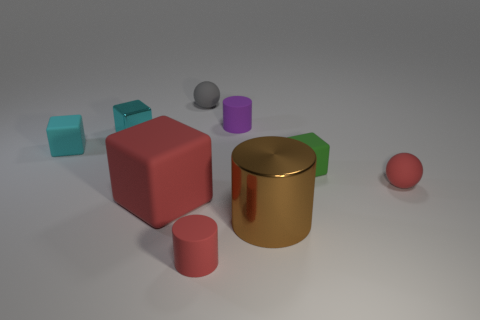Subtract all small purple matte cylinders. How many cylinders are left? 2 Subtract all blocks. How many objects are left? 5 Add 1 big brown things. How many objects exist? 10 Subtract all cyan cubes. How many cubes are left? 2 Subtract all green cylinders. Subtract all cyan cubes. How many cylinders are left? 3 Subtract all brown balls. How many cyan cubes are left? 2 Subtract all big objects. Subtract all purple rubber things. How many objects are left? 6 Add 4 small cyan objects. How many small cyan objects are left? 6 Add 4 red rubber spheres. How many red rubber spheres exist? 5 Subtract 0 gray blocks. How many objects are left? 9 